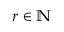Convert formula to latex. <formula><loc_0><loc_0><loc_500><loc_500>r \in \mathbb { N }</formula> 